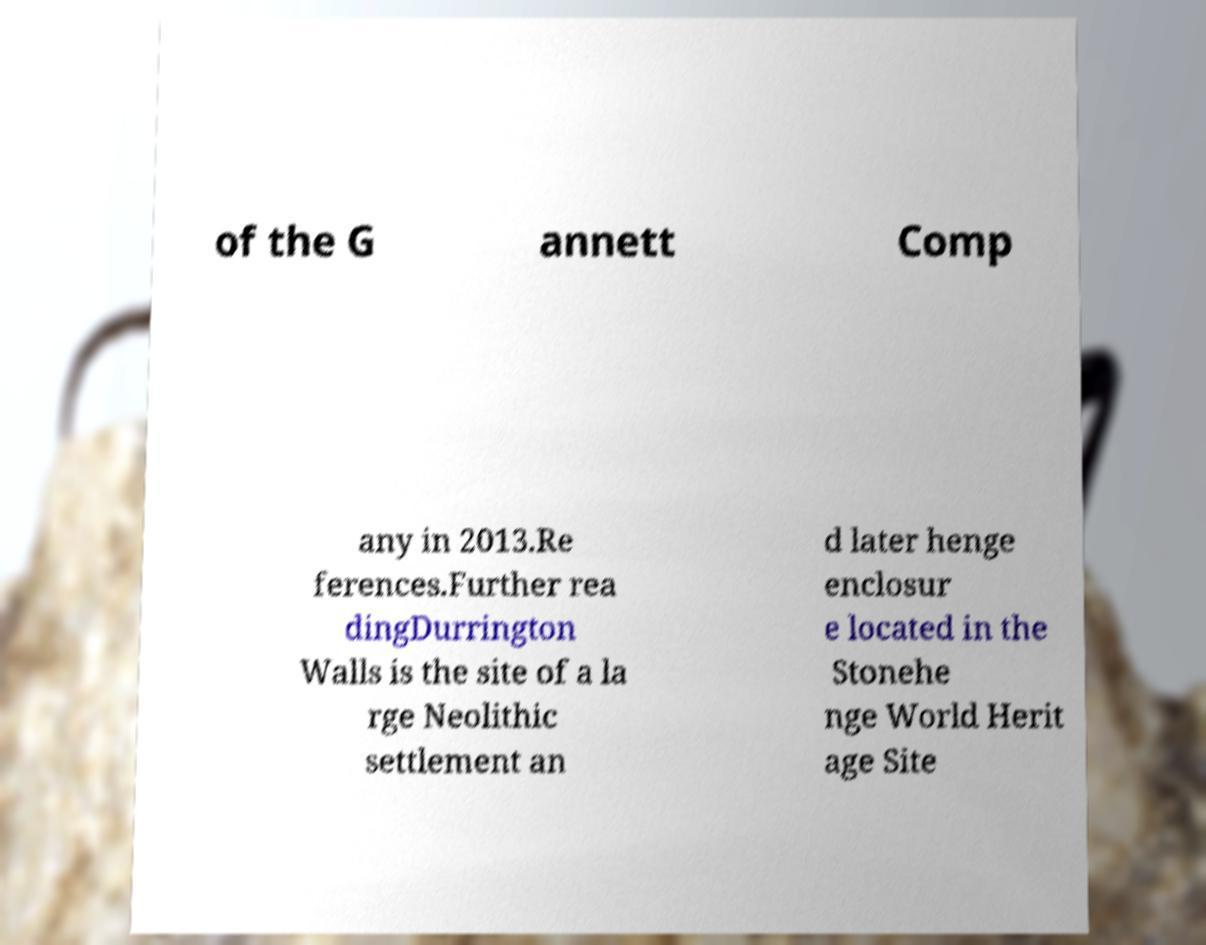What messages or text are displayed in this image? I need them in a readable, typed format. of the G annett Comp any in 2013.Re ferences.Further rea dingDurrington Walls is the site of a la rge Neolithic settlement an d later henge enclosur e located in the Stonehe nge World Herit age Site 